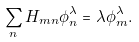Convert formula to latex. <formula><loc_0><loc_0><loc_500><loc_500>\sum _ { n } H _ { m n } \phi _ { n } ^ { \lambda } = \lambda \phi _ { m } ^ { \lambda } .</formula> 